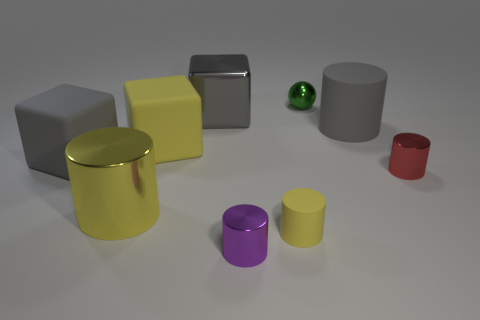Subtract all purple cylinders. How many cylinders are left? 4 Subtract all green cylinders. Subtract all yellow balls. How many cylinders are left? 5 Add 1 cyan metallic things. How many objects exist? 10 Subtract all cylinders. How many objects are left? 4 Subtract 0 blue cylinders. How many objects are left? 9 Subtract all big gray blocks. Subtract all gray objects. How many objects are left? 4 Add 8 small metal cylinders. How many small metal cylinders are left? 10 Add 8 brown metal cylinders. How many brown metal cylinders exist? 8 